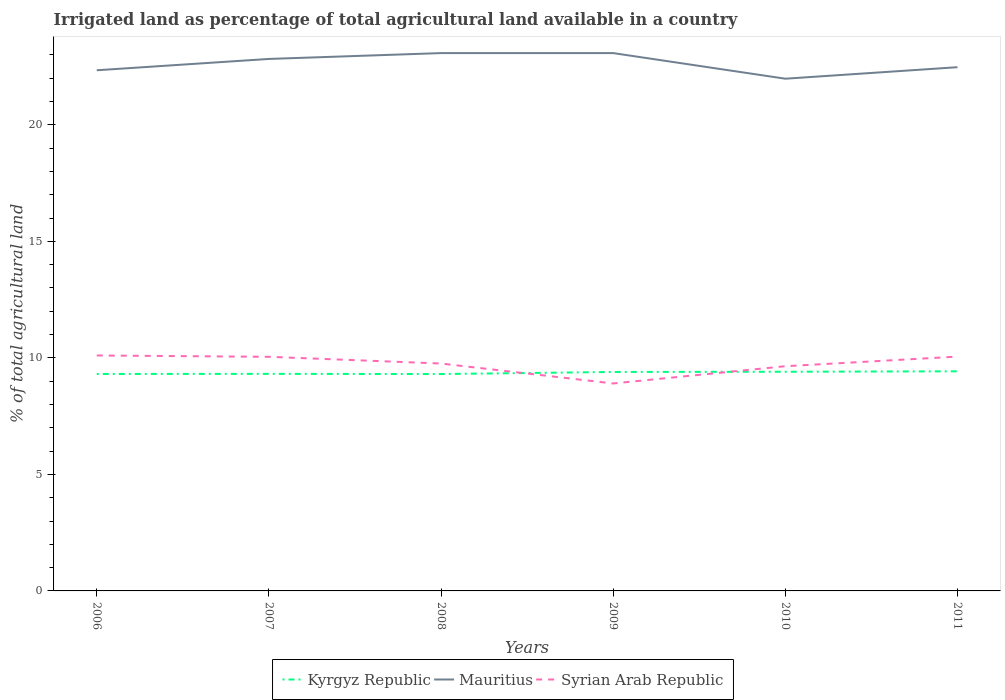How many different coloured lines are there?
Offer a very short reply. 3. Does the line corresponding to Syrian Arab Republic intersect with the line corresponding to Kyrgyz Republic?
Your answer should be compact. Yes. Is the number of lines equal to the number of legend labels?
Make the answer very short. Yes. Across all years, what is the maximum percentage of irrigated land in Kyrgyz Republic?
Your answer should be compact. 9.31. In which year was the percentage of irrigated land in Syrian Arab Republic maximum?
Your response must be concise. 2009. What is the total percentage of irrigated land in Syrian Arab Republic in the graph?
Provide a short and direct response. 0.05. What is the difference between the highest and the second highest percentage of irrigated land in Syrian Arab Republic?
Provide a short and direct response. 1.2. How many lines are there?
Your answer should be compact. 3. How many years are there in the graph?
Your answer should be compact. 6. Where does the legend appear in the graph?
Your answer should be very brief. Bottom center. How many legend labels are there?
Give a very brief answer. 3. How are the legend labels stacked?
Your answer should be compact. Horizontal. What is the title of the graph?
Provide a short and direct response. Irrigated land as percentage of total agricultural land available in a country. What is the label or title of the X-axis?
Your answer should be compact. Years. What is the label or title of the Y-axis?
Offer a terse response. % of total agricultural land. What is the % of total agricultural land of Kyrgyz Republic in 2006?
Give a very brief answer. 9.31. What is the % of total agricultural land of Mauritius in 2006?
Offer a terse response. 22.34. What is the % of total agricultural land of Syrian Arab Republic in 2006?
Keep it short and to the point. 10.1. What is the % of total agricultural land of Kyrgyz Republic in 2007?
Make the answer very short. 9.31. What is the % of total agricultural land of Mauritius in 2007?
Offer a terse response. 22.83. What is the % of total agricultural land in Syrian Arab Republic in 2007?
Offer a very short reply. 10.05. What is the % of total agricultural land in Kyrgyz Republic in 2008?
Give a very brief answer. 9.31. What is the % of total agricultural land in Mauritius in 2008?
Your response must be concise. 23.08. What is the % of total agricultural land in Syrian Arab Republic in 2008?
Offer a terse response. 9.76. What is the % of total agricultural land in Kyrgyz Republic in 2009?
Ensure brevity in your answer.  9.4. What is the % of total agricultural land of Mauritius in 2009?
Provide a succinct answer. 23.08. What is the % of total agricultural land in Syrian Arab Republic in 2009?
Provide a succinct answer. 8.9. What is the % of total agricultural land of Kyrgyz Republic in 2010?
Offer a very short reply. 9.4. What is the % of total agricultural land in Mauritius in 2010?
Provide a short and direct response. 21.98. What is the % of total agricultural land of Syrian Arab Republic in 2010?
Make the answer very short. 9.64. What is the % of total agricultural land in Kyrgyz Republic in 2011?
Ensure brevity in your answer.  9.42. What is the % of total agricultural land in Mauritius in 2011?
Your response must be concise. 22.47. What is the % of total agricultural land in Syrian Arab Republic in 2011?
Your answer should be compact. 10.05. Across all years, what is the maximum % of total agricultural land in Kyrgyz Republic?
Provide a succinct answer. 9.42. Across all years, what is the maximum % of total agricultural land in Mauritius?
Your answer should be very brief. 23.08. Across all years, what is the maximum % of total agricultural land in Syrian Arab Republic?
Provide a succinct answer. 10.1. Across all years, what is the minimum % of total agricultural land of Kyrgyz Republic?
Your answer should be very brief. 9.31. Across all years, what is the minimum % of total agricultural land in Mauritius?
Offer a terse response. 21.98. Across all years, what is the minimum % of total agricultural land of Syrian Arab Republic?
Your answer should be very brief. 8.9. What is the total % of total agricultural land in Kyrgyz Republic in the graph?
Make the answer very short. 56.15. What is the total % of total agricultural land in Mauritius in the graph?
Provide a succinct answer. 135.77. What is the total % of total agricultural land in Syrian Arab Republic in the graph?
Your response must be concise. 58.5. What is the difference between the % of total agricultural land in Kyrgyz Republic in 2006 and that in 2007?
Offer a terse response. -0.01. What is the difference between the % of total agricultural land of Mauritius in 2006 and that in 2007?
Provide a succinct answer. -0.49. What is the difference between the % of total agricultural land in Syrian Arab Republic in 2006 and that in 2007?
Your answer should be compact. 0.06. What is the difference between the % of total agricultural land of Kyrgyz Republic in 2006 and that in 2008?
Make the answer very short. 0. What is the difference between the % of total agricultural land of Mauritius in 2006 and that in 2008?
Ensure brevity in your answer.  -0.74. What is the difference between the % of total agricultural land in Syrian Arab Republic in 2006 and that in 2008?
Ensure brevity in your answer.  0.35. What is the difference between the % of total agricultural land in Kyrgyz Republic in 2006 and that in 2009?
Your answer should be compact. -0.09. What is the difference between the % of total agricultural land of Mauritius in 2006 and that in 2009?
Make the answer very short. -0.74. What is the difference between the % of total agricultural land of Syrian Arab Republic in 2006 and that in 2009?
Make the answer very short. 1.2. What is the difference between the % of total agricultural land of Kyrgyz Republic in 2006 and that in 2010?
Your answer should be very brief. -0.1. What is the difference between the % of total agricultural land in Mauritius in 2006 and that in 2010?
Your answer should be compact. 0.36. What is the difference between the % of total agricultural land in Syrian Arab Republic in 2006 and that in 2010?
Offer a terse response. 0.46. What is the difference between the % of total agricultural land in Kyrgyz Republic in 2006 and that in 2011?
Provide a succinct answer. -0.11. What is the difference between the % of total agricultural land in Mauritius in 2006 and that in 2011?
Your answer should be compact. -0.13. What is the difference between the % of total agricultural land in Syrian Arab Republic in 2006 and that in 2011?
Make the answer very short. 0.05. What is the difference between the % of total agricultural land of Kyrgyz Republic in 2007 and that in 2008?
Your answer should be compact. 0.01. What is the difference between the % of total agricultural land in Mauritius in 2007 and that in 2008?
Provide a succinct answer. -0.25. What is the difference between the % of total agricultural land of Syrian Arab Republic in 2007 and that in 2008?
Make the answer very short. 0.29. What is the difference between the % of total agricultural land in Kyrgyz Republic in 2007 and that in 2009?
Make the answer very short. -0.08. What is the difference between the % of total agricultural land in Mauritius in 2007 and that in 2009?
Provide a short and direct response. -0.25. What is the difference between the % of total agricultural land in Syrian Arab Republic in 2007 and that in 2009?
Your answer should be very brief. 1.14. What is the difference between the % of total agricultural land of Kyrgyz Republic in 2007 and that in 2010?
Keep it short and to the point. -0.09. What is the difference between the % of total agricultural land in Mauritius in 2007 and that in 2010?
Give a very brief answer. 0.85. What is the difference between the % of total agricultural land of Syrian Arab Republic in 2007 and that in 2010?
Make the answer very short. 0.4. What is the difference between the % of total agricultural land of Kyrgyz Republic in 2007 and that in 2011?
Give a very brief answer. -0.11. What is the difference between the % of total agricultural land in Mauritius in 2007 and that in 2011?
Give a very brief answer. 0.35. What is the difference between the % of total agricultural land in Syrian Arab Republic in 2007 and that in 2011?
Ensure brevity in your answer.  -0.01. What is the difference between the % of total agricultural land of Kyrgyz Republic in 2008 and that in 2009?
Your answer should be very brief. -0.09. What is the difference between the % of total agricultural land in Mauritius in 2008 and that in 2009?
Provide a short and direct response. 0. What is the difference between the % of total agricultural land in Syrian Arab Republic in 2008 and that in 2009?
Your answer should be compact. 0.86. What is the difference between the % of total agricultural land of Kyrgyz Republic in 2008 and that in 2010?
Keep it short and to the point. -0.1. What is the difference between the % of total agricultural land of Mauritius in 2008 and that in 2010?
Make the answer very short. 1.1. What is the difference between the % of total agricultural land of Syrian Arab Republic in 2008 and that in 2010?
Your answer should be very brief. 0.11. What is the difference between the % of total agricultural land of Kyrgyz Republic in 2008 and that in 2011?
Give a very brief answer. -0.12. What is the difference between the % of total agricultural land of Mauritius in 2008 and that in 2011?
Your answer should be compact. 0.6. What is the difference between the % of total agricultural land in Syrian Arab Republic in 2008 and that in 2011?
Your answer should be compact. -0.3. What is the difference between the % of total agricultural land in Kyrgyz Republic in 2009 and that in 2010?
Give a very brief answer. -0.01. What is the difference between the % of total agricultural land in Mauritius in 2009 and that in 2010?
Provide a short and direct response. 1.1. What is the difference between the % of total agricultural land of Syrian Arab Republic in 2009 and that in 2010?
Provide a short and direct response. -0.74. What is the difference between the % of total agricultural land in Kyrgyz Republic in 2009 and that in 2011?
Ensure brevity in your answer.  -0.03. What is the difference between the % of total agricultural land of Mauritius in 2009 and that in 2011?
Your response must be concise. 0.6. What is the difference between the % of total agricultural land of Syrian Arab Republic in 2009 and that in 2011?
Provide a short and direct response. -1.15. What is the difference between the % of total agricultural land of Kyrgyz Republic in 2010 and that in 2011?
Your answer should be compact. -0.02. What is the difference between the % of total agricultural land in Mauritius in 2010 and that in 2011?
Your answer should be compact. -0.49. What is the difference between the % of total agricultural land of Syrian Arab Republic in 2010 and that in 2011?
Your answer should be compact. -0.41. What is the difference between the % of total agricultural land in Kyrgyz Republic in 2006 and the % of total agricultural land in Mauritius in 2007?
Make the answer very short. -13.52. What is the difference between the % of total agricultural land of Kyrgyz Republic in 2006 and the % of total agricultural land of Syrian Arab Republic in 2007?
Provide a succinct answer. -0.74. What is the difference between the % of total agricultural land in Mauritius in 2006 and the % of total agricultural land in Syrian Arab Republic in 2007?
Keep it short and to the point. 12.3. What is the difference between the % of total agricultural land in Kyrgyz Republic in 2006 and the % of total agricultural land in Mauritius in 2008?
Keep it short and to the point. -13.77. What is the difference between the % of total agricultural land of Kyrgyz Republic in 2006 and the % of total agricultural land of Syrian Arab Republic in 2008?
Your answer should be compact. -0.45. What is the difference between the % of total agricultural land of Mauritius in 2006 and the % of total agricultural land of Syrian Arab Republic in 2008?
Give a very brief answer. 12.58. What is the difference between the % of total agricultural land of Kyrgyz Republic in 2006 and the % of total agricultural land of Mauritius in 2009?
Give a very brief answer. -13.77. What is the difference between the % of total agricultural land in Kyrgyz Republic in 2006 and the % of total agricultural land in Syrian Arab Republic in 2009?
Ensure brevity in your answer.  0.41. What is the difference between the % of total agricultural land of Mauritius in 2006 and the % of total agricultural land of Syrian Arab Republic in 2009?
Give a very brief answer. 13.44. What is the difference between the % of total agricultural land of Kyrgyz Republic in 2006 and the % of total agricultural land of Mauritius in 2010?
Ensure brevity in your answer.  -12.67. What is the difference between the % of total agricultural land in Kyrgyz Republic in 2006 and the % of total agricultural land in Syrian Arab Republic in 2010?
Ensure brevity in your answer.  -0.33. What is the difference between the % of total agricultural land of Mauritius in 2006 and the % of total agricultural land of Syrian Arab Republic in 2010?
Offer a very short reply. 12.7. What is the difference between the % of total agricultural land in Kyrgyz Republic in 2006 and the % of total agricultural land in Mauritius in 2011?
Offer a terse response. -13.16. What is the difference between the % of total agricultural land of Kyrgyz Republic in 2006 and the % of total agricultural land of Syrian Arab Republic in 2011?
Make the answer very short. -0.75. What is the difference between the % of total agricultural land of Mauritius in 2006 and the % of total agricultural land of Syrian Arab Republic in 2011?
Provide a succinct answer. 12.29. What is the difference between the % of total agricultural land in Kyrgyz Republic in 2007 and the % of total agricultural land in Mauritius in 2008?
Your response must be concise. -13.76. What is the difference between the % of total agricultural land of Kyrgyz Republic in 2007 and the % of total agricultural land of Syrian Arab Republic in 2008?
Provide a succinct answer. -0.44. What is the difference between the % of total agricultural land in Mauritius in 2007 and the % of total agricultural land in Syrian Arab Republic in 2008?
Ensure brevity in your answer.  13.07. What is the difference between the % of total agricultural land in Kyrgyz Republic in 2007 and the % of total agricultural land in Mauritius in 2009?
Provide a short and direct response. -13.76. What is the difference between the % of total agricultural land in Kyrgyz Republic in 2007 and the % of total agricultural land in Syrian Arab Republic in 2009?
Your answer should be very brief. 0.41. What is the difference between the % of total agricultural land of Mauritius in 2007 and the % of total agricultural land of Syrian Arab Republic in 2009?
Provide a short and direct response. 13.92. What is the difference between the % of total agricultural land of Kyrgyz Republic in 2007 and the % of total agricultural land of Mauritius in 2010?
Offer a very short reply. -12.66. What is the difference between the % of total agricultural land in Kyrgyz Republic in 2007 and the % of total agricultural land in Syrian Arab Republic in 2010?
Your answer should be very brief. -0.33. What is the difference between the % of total agricultural land of Mauritius in 2007 and the % of total agricultural land of Syrian Arab Republic in 2010?
Give a very brief answer. 13.18. What is the difference between the % of total agricultural land of Kyrgyz Republic in 2007 and the % of total agricultural land of Mauritius in 2011?
Give a very brief answer. -13.16. What is the difference between the % of total agricultural land of Kyrgyz Republic in 2007 and the % of total agricultural land of Syrian Arab Republic in 2011?
Make the answer very short. -0.74. What is the difference between the % of total agricultural land of Mauritius in 2007 and the % of total agricultural land of Syrian Arab Republic in 2011?
Provide a short and direct response. 12.77. What is the difference between the % of total agricultural land in Kyrgyz Republic in 2008 and the % of total agricultural land in Mauritius in 2009?
Make the answer very short. -13.77. What is the difference between the % of total agricultural land of Kyrgyz Republic in 2008 and the % of total agricultural land of Syrian Arab Republic in 2009?
Provide a succinct answer. 0.4. What is the difference between the % of total agricultural land in Mauritius in 2008 and the % of total agricultural land in Syrian Arab Republic in 2009?
Keep it short and to the point. 14.18. What is the difference between the % of total agricultural land in Kyrgyz Republic in 2008 and the % of total agricultural land in Mauritius in 2010?
Your answer should be very brief. -12.67. What is the difference between the % of total agricultural land in Kyrgyz Republic in 2008 and the % of total agricultural land in Syrian Arab Republic in 2010?
Your answer should be compact. -0.34. What is the difference between the % of total agricultural land in Mauritius in 2008 and the % of total agricultural land in Syrian Arab Republic in 2010?
Give a very brief answer. 13.44. What is the difference between the % of total agricultural land in Kyrgyz Republic in 2008 and the % of total agricultural land in Mauritius in 2011?
Your response must be concise. -13.17. What is the difference between the % of total agricultural land in Kyrgyz Republic in 2008 and the % of total agricultural land in Syrian Arab Republic in 2011?
Your answer should be compact. -0.75. What is the difference between the % of total agricultural land of Mauritius in 2008 and the % of total agricultural land of Syrian Arab Republic in 2011?
Make the answer very short. 13.02. What is the difference between the % of total agricultural land in Kyrgyz Republic in 2009 and the % of total agricultural land in Mauritius in 2010?
Ensure brevity in your answer.  -12.58. What is the difference between the % of total agricultural land of Kyrgyz Republic in 2009 and the % of total agricultural land of Syrian Arab Republic in 2010?
Your answer should be compact. -0.25. What is the difference between the % of total agricultural land of Mauritius in 2009 and the % of total agricultural land of Syrian Arab Republic in 2010?
Your response must be concise. 13.44. What is the difference between the % of total agricultural land of Kyrgyz Republic in 2009 and the % of total agricultural land of Mauritius in 2011?
Offer a very short reply. -13.08. What is the difference between the % of total agricultural land in Kyrgyz Republic in 2009 and the % of total agricultural land in Syrian Arab Republic in 2011?
Ensure brevity in your answer.  -0.66. What is the difference between the % of total agricultural land in Mauritius in 2009 and the % of total agricultural land in Syrian Arab Republic in 2011?
Make the answer very short. 13.02. What is the difference between the % of total agricultural land in Kyrgyz Republic in 2010 and the % of total agricultural land in Mauritius in 2011?
Make the answer very short. -13.07. What is the difference between the % of total agricultural land of Kyrgyz Republic in 2010 and the % of total agricultural land of Syrian Arab Republic in 2011?
Your answer should be very brief. -0.65. What is the difference between the % of total agricultural land of Mauritius in 2010 and the % of total agricultural land of Syrian Arab Republic in 2011?
Offer a terse response. 11.92. What is the average % of total agricultural land of Kyrgyz Republic per year?
Give a very brief answer. 9.36. What is the average % of total agricultural land of Mauritius per year?
Your answer should be very brief. 22.63. What is the average % of total agricultural land of Syrian Arab Republic per year?
Make the answer very short. 9.75. In the year 2006, what is the difference between the % of total agricultural land in Kyrgyz Republic and % of total agricultural land in Mauritius?
Your answer should be compact. -13.03. In the year 2006, what is the difference between the % of total agricultural land of Kyrgyz Republic and % of total agricultural land of Syrian Arab Republic?
Your answer should be compact. -0.79. In the year 2006, what is the difference between the % of total agricultural land in Mauritius and % of total agricultural land in Syrian Arab Republic?
Give a very brief answer. 12.24. In the year 2007, what is the difference between the % of total agricultural land of Kyrgyz Republic and % of total agricultural land of Mauritius?
Make the answer very short. -13.51. In the year 2007, what is the difference between the % of total agricultural land of Kyrgyz Republic and % of total agricultural land of Syrian Arab Republic?
Offer a very short reply. -0.73. In the year 2007, what is the difference between the % of total agricultural land in Mauritius and % of total agricultural land in Syrian Arab Republic?
Your answer should be compact. 12.78. In the year 2008, what is the difference between the % of total agricultural land in Kyrgyz Republic and % of total agricultural land in Mauritius?
Offer a very short reply. -13.77. In the year 2008, what is the difference between the % of total agricultural land of Kyrgyz Republic and % of total agricultural land of Syrian Arab Republic?
Make the answer very short. -0.45. In the year 2008, what is the difference between the % of total agricultural land in Mauritius and % of total agricultural land in Syrian Arab Republic?
Ensure brevity in your answer.  13.32. In the year 2009, what is the difference between the % of total agricultural land in Kyrgyz Republic and % of total agricultural land in Mauritius?
Keep it short and to the point. -13.68. In the year 2009, what is the difference between the % of total agricultural land in Kyrgyz Republic and % of total agricultural land in Syrian Arab Republic?
Offer a very short reply. 0.49. In the year 2009, what is the difference between the % of total agricultural land in Mauritius and % of total agricultural land in Syrian Arab Republic?
Your answer should be compact. 14.18. In the year 2010, what is the difference between the % of total agricultural land in Kyrgyz Republic and % of total agricultural land in Mauritius?
Your answer should be very brief. -12.57. In the year 2010, what is the difference between the % of total agricultural land in Kyrgyz Republic and % of total agricultural land in Syrian Arab Republic?
Your response must be concise. -0.24. In the year 2010, what is the difference between the % of total agricultural land in Mauritius and % of total agricultural land in Syrian Arab Republic?
Keep it short and to the point. 12.34. In the year 2011, what is the difference between the % of total agricultural land of Kyrgyz Republic and % of total agricultural land of Mauritius?
Make the answer very short. -13.05. In the year 2011, what is the difference between the % of total agricultural land in Kyrgyz Republic and % of total agricultural land in Syrian Arab Republic?
Your answer should be compact. -0.63. In the year 2011, what is the difference between the % of total agricultural land of Mauritius and % of total agricultural land of Syrian Arab Republic?
Your answer should be very brief. 12.42. What is the ratio of the % of total agricultural land of Mauritius in 2006 to that in 2007?
Provide a succinct answer. 0.98. What is the ratio of the % of total agricultural land of Syrian Arab Republic in 2006 to that in 2007?
Your answer should be very brief. 1.01. What is the ratio of the % of total agricultural land of Mauritius in 2006 to that in 2008?
Give a very brief answer. 0.97. What is the ratio of the % of total agricultural land in Syrian Arab Republic in 2006 to that in 2008?
Your response must be concise. 1.04. What is the ratio of the % of total agricultural land in Kyrgyz Republic in 2006 to that in 2009?
Your answer should be compact. 0.99. What is the ratio of the % of total agricultural land of Mauritius in 2006 to that in 2009?
Offer a terse response. 0.97. What is the ratio of the % of total agricultural land of Syrian Arab Republic in 2006 to that in 2009?
Provide a short and direct response. 1.14. What is the ratio of the % of total agricultural land in Kyrgyz Republic in 2006 to that in 2010?
Your response must be concise. 0.99. What is the ratio of the % of total agricultural land of Mauritius in 2006 to that in 2010?
Provide a succinct answer. 1.02. What is the ratio of the % of total agricultural land in Syrian Arab Republic in 2006 to that in 2010?
Provide a succinct answer. 1.05. What is the ratio of the % of total agricultural land in Kyrgyz Republic in 2006 to that in 2011?
Make the answer very short. 0.99. What is the ratio of the % of total agricultural land in Syrian Arab Republic in 2006 to that in 2011?
Ensure brevity in your answer.  1. What is the ratio of the % of total agricultural land of Mauritius in 2007 to that in 2008?
Ensure brevity in your answer.  0.99. What is the ratio of the % of total agricultural land in Syrian Arab Republic in 2007 to that in 2008?
Give a very brief answer. 1.03. What is the ratio of the % of total agricultural land of Kyrgyz Republic in 2007 to that in 2009?
Offer a terse response. 0.99. What is the ratio of the % of total agricultural land in Syrian Arab Republic in 2007 to that in 2009?
Your answer should be compact. 1.13. What is the ratio of the % of total agricultural land in Kyrgyz Republic in 2007 to that in 2010?
Give a very brief answer. 0.99. What is the ratio of the % of total agricultural land in Mauritius in 2007 to that in 2010?
Provide a short and direct response. 1.04. What is the ratio of the % of total agricultural land in Syrian Arab Republic in 2007 to that in 2010?
Offer a terse response. 1.04. What is the ratio of the % of total agricultural land in Kyrgyz Republic in 2007 to that in 2011?
Offer a very short reply. 0.99. What is the ratio of the % of total agricultural land in Mauritius in 2007 to that in 2011?
Ensure brevity in your answer.  1.02. What is the ratio of the % of total agricultural land of Syrian Arab Republic in 2007 to that in 2011?
Give a very brief answer. 1. What is the ratio of the % of total agricultural land of Kyrgyz Republic in 2008 to that in 2009?
Offer a terse response. 0.99. What is the ratio of the % of total agricultural land in Mauritius in 2008 to that in 2009?
Your response must be concise. 1. What is the ratio of the % of total agricultural land in Syrian Arab Republic in 2008 to that in 2009?
Offer a terse response. 1.1. What is the ratio of the % of total agricultural land of Kyrgyz Republic in 2008 to that in 2010?
Provide a succinct answer. 0.99. What is the ratio of the % of total agricultural land in Mauritius in 2008 to that in 2010?
Your answer should be compact. 1.05. What is the ratio of the % of total agricultural land of Syrian Arab Republic in 2008 to that in 2010?
Make the answer very short. 1.01. What is the ratio of the % of total agricultural land of Kyrgyz Republic in 2008 to that in 2011?
Your answer should be compact. 0.99. What is the ratio of the % of total agricultural land in Mauritius in 2008 to that in 2011?
Your answer should be very brief. 1.03. What is the ratio of the % of total agricultural land of Syrian Arab Republic in 2008 to that in 2011?
Your answer should be very brief. 0.97. What is the ratio of the % of total agricultural land in Mauritius in 2009 to that in 2010?
Ensure brevity in your answer.  1.05. What is the ratio of the % of total agricultural land of Syrian Arab Republic in 2009 to that in 2010?
Your response must be concise. 0.92. What is the ratio of the % of total agricultural land of Mauritius in 2009 to that in 2011?
Your answer should be compact. 1.03. What is the ratio of the % of total agricultural land of Syrian Arab Republic in 2009 to that in 2011?
Make the answer very short. 0.89. What is the ratio of the % of total agricultural land of Syrian Arab Republic in 2010 to that in 2011?
Your answer should be compact. 0.96. What is the difference between the highest and the second highest % of total agricultural land of Kyrgyz Republic?
Keep it short and to the point. 0.02. What is the difference between the highest and the second highest % of total agricultural land in Mauritius?
Provide a short and direct response. 0. What is the difference between the highest and the second highest % of total agricultural land of Syrian Arab Republic?
Offer a terse response. 0.05. What is the difference between the highest and the lowest % of total agricultural land of Kyrgyz Republic?
Your answer should be very brief. 0.12. What is the difference between the highest and the lowest % of total agricultural land of Mauritius?
Make the answer very short. 1.1. What is the difference between the highest and the lowest % of total agricultural land of Syrian Arab Republic?
Make the answer very short. 1.2. 